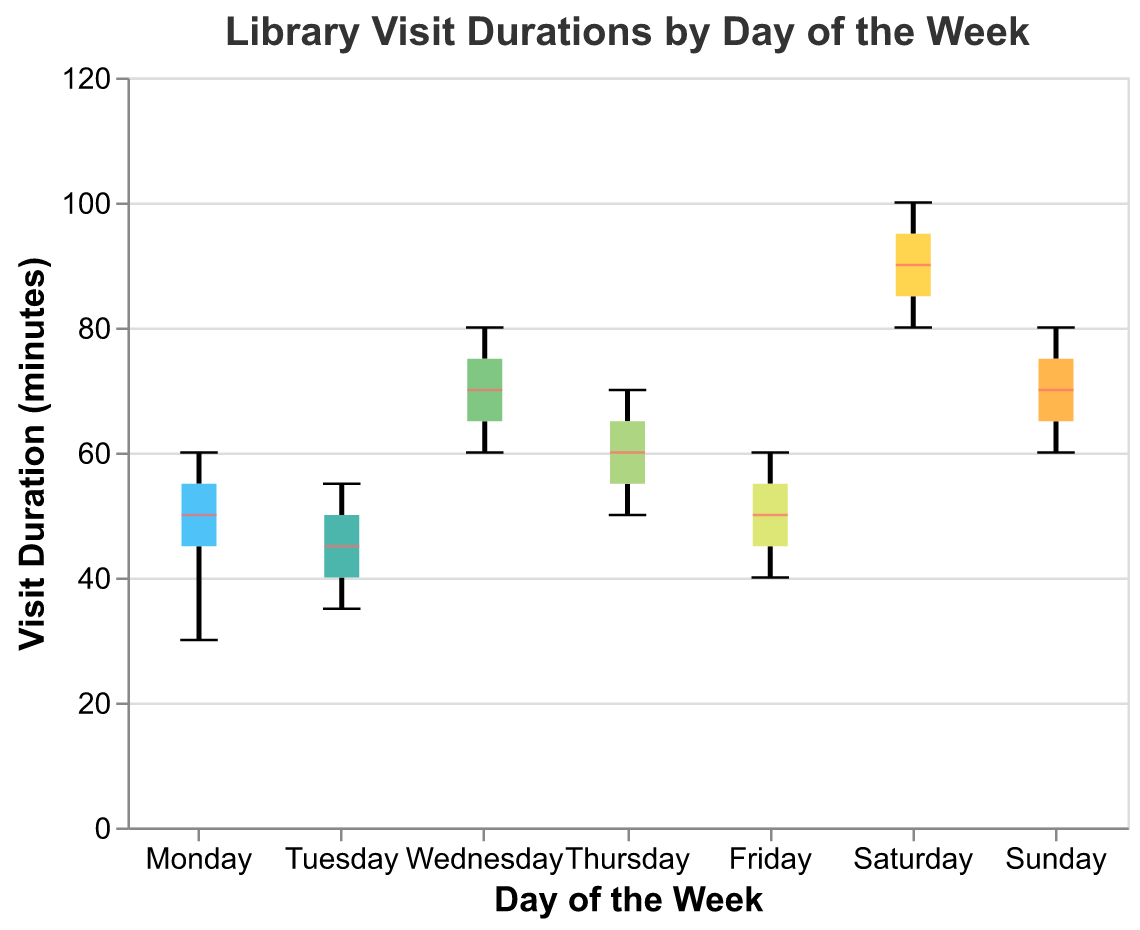What is the title of the figure? The title is displayed at the top of the figure. It reads "Library Visit Durations by Day of the Week".
Answer: Library Visit Durations by Day of the Week What is the maximum visit duration recorded on Saturday? The box plot for Saturday shows the spread of the data points, and the highest value within the whiskers represents the maximum. The plot indicates it is 100 minutes.
Answer: 100 minutes Which day has the highest median visit duration? The median is marked by a distinct line within the boxes. By comparing the medians across all days, Saturday has the highest median visit duration.
Answer: Saturday What is the range of visit durations on Wednesday? The range is found by subtracting the minimum value from the maximum value shown by the whiskers on the box plot for Wednesday. The minimum is 60 minutes and the maximum is 80 minutes; thus, the range is 80 - 60 = 20 minutes.
Answer: 20 minutes Which two days have the smallest interquartile range (IQR) for visit durations? The IQR is represented by the length of the box. By visually comparing the box sizes, Thursday and Friday have the smallest IQRs.
Answer: Thursday and Friday How do the visit durations on Monday compare with those on Wednesday? By comparing the box plots for Monday and Wednesday:
- Monday's durations range from 30 to 60 minutes, with a median around 50 minutes.
- Wednesday's durations range from 60 to 80 minutes, with a median around 70 minutes.
So, Wednesday generally has higher visit durations.
Answer: Wednesday has higher visit durations On which day is the visit duration distribution the most spread out? The spread of the distribution can be assessed by the range between the minimum and maximum values as shown by the whiskers. Saturday has the widest spread, with durations ranging from 80 to 100 minutes.
Answer: Saturday Which day has the shortest median visit duration? The median visit duration can be found by looking at the middle line within each box. Tuesday has the shortest median around 45 minutes.
Answer: Tuesday What are the median visit durations on Thursday and Friday? The median is the middle line within the boxes:
- Thursday's median is at 60 minutes.
- Friday's median is at 50 minutes.
Answer: Thursday: 60 minutes, Friday: 50 minutes 